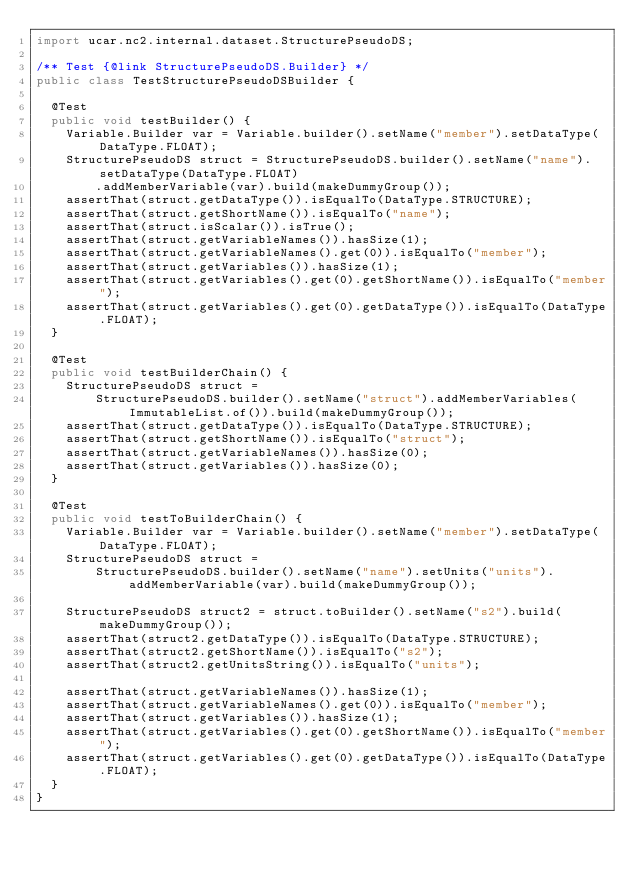<code> <loc_0><loc_0><loc_500><loc_500><_Java_>import ucar.nc2.internal.dataset.StructurePseudoDS;

/** Test {@link StructurePseudoDS.Builder} */
public class TestStructurePseudoDSBuilder {

  @Test
  public void testBuilder() {
    Variable.Builder var = Variable.builder().setName("member").setDataType(DataType.FLOAT);
    StructurePseudoDS struct = StructurePseudoDS.builder().setName("name").setDataType(DataType.FLOAT)
        .addMemberVariable(var).build(makeDummyGroup());
    assertThat(struct.getDataType()).isEqualTo(DataType.STRUCTURE);
    assertThat(struct.getShortName()).isEqualTo("name");
    assertThat(struct.isScalar()).isTrue();
    assertThat(struct.getVariableNames()).hasSize(1);
    assertThat(struct.getVariableNames().get(0)).isEqualTo("member");
    assertThat(struct.getVariables()).hasSize(1);
    assertThat(struct.getVariables().get(0).getShortName()).isEqualTo("member");
    assertThat(struct.getVariables().get(0).getDataType()).isEqualTo(DataType.FLOAT);
  }

  @Test
  public void testBuilderChain() {
    StructurePseudoDS struct =
        StructurePseudoDS.builder().setName("struct").addMemberVariables(ImmutableList.of()).build(makeDummyGroup());
    assertThat(struct.getDataType()).isEqualTo(DataType.STRUCTURE);
    assertThat(struct.getShortName()).isEqualTo("struct");
    assertThat(struct.getVariableNames()).hasSize(0);
    assertThat(struct.getVariables()).hasSize(0);
  }

  @Test
  public void testToBuilderChain() {
    Variable.Builder var = Variable.builder().setName("member").setDataType(DataType.FLOAT);
    StructurePseudoDS struct =
        StructurePseudoDS.builder().setName("name").setUnits("units").addMemberVariable(var).build(makeDummyGroup());

    StructurePseudoDS struct2 = struct.toBuilder().setName("s2").build(makeDummyGroup());
    assertThat(struct2.getDataType()).isEqualTo(DataType.STRUCTURE);
    assertThat(struct2.getShortName()).isEqualTo("s2");
    assertThat(struct2.getUnitsString()).isEqualTo("units");

    assertThat(struct.getVariableNames()).hasSize(1);
    assertThat(struct.getVariableNames().get(0)).isEqualTo("member");
    assertThat(struct.getVariables()).hasSize(1);
    assertThat(struct.getVariables().get(0).getShortName()).isEqualTo("member");
    assertThat(struct.getVariables().get(0).getDataType()).isEqualTo(DataType.FLOAT);
  }
}
</code> 